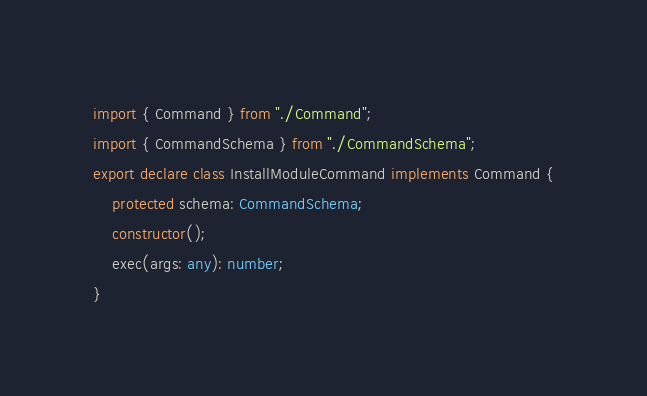<code> <loc_0><loc_0><loc_500><loc_500><_TypeScript_>import { Command } from "./Command";
import { CommandSchema } from "./CommandSchema";
export declare class InstallModuleCommand implements Command {
    protected schema: CommandSchema;
    constructor();
    exec(args: any): number;
}
</code> 